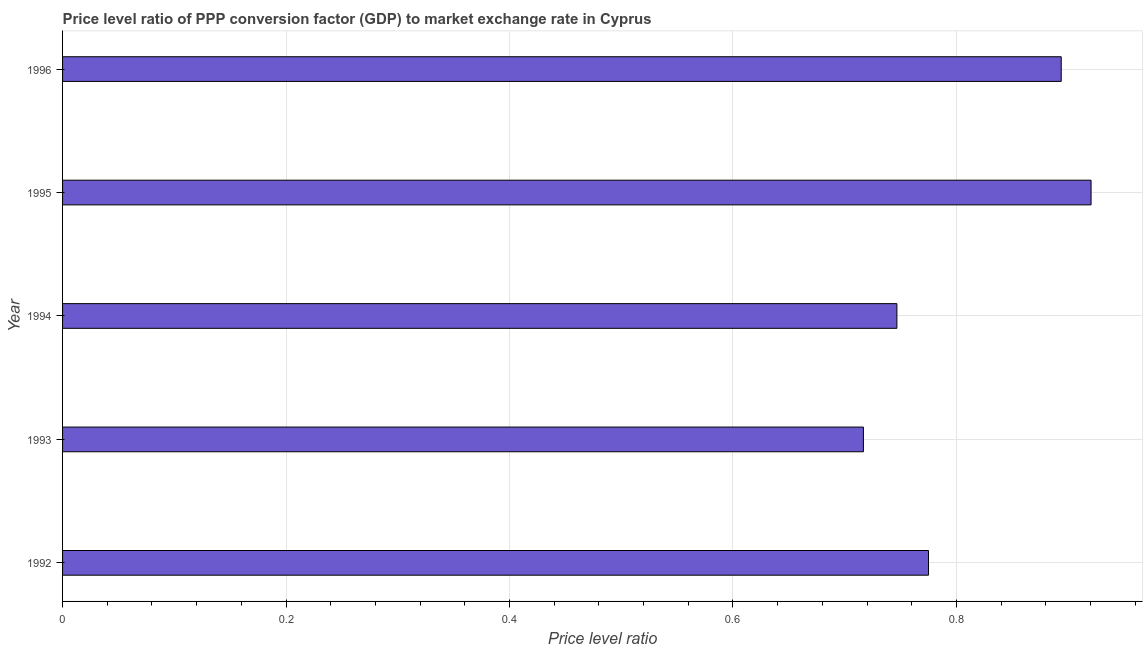Does the graph contain any zero values?
Keep it short and to the point. No. What is the title of the graph?
Provide a short and direct response. Price level ratio of PPP conversion factor (GDP) to market exchange rate in Cyprus. What is the label or title of the X-axis?
Your response must be concise. Price level ratio. What is the price level ratio in 1996?
Keep it short and to the point. 0.89. Across all years, what is the maximum price level ratio?
Your answer should be compact. 0.92. Across all years, what is the minimum price level ratio?
Offer a very short reply. 0.72. In which year was the price level ratio minimum?
Your answer should be very brief. 1993. What is the sum of the price level ratio?
Your answer should be very brief. 4.05. What is the difference between the price level ratio in 1992 and 1993?
Make the answer very short. 0.06. What is the average price level ratio per year?
Provide a succinct answer. 0.81. What is the median price level ratio?
Make the answer very short. 0.77. In how many years, is the price level ratio greater than 0.8 ?
Give a very brief answer. 2. What is the ratio of the price level ratio in 1995 to that in 1996?
Make the answer very short. 1.03. Is the price level ratio in 1993 less than that in 1994?
Your response must be concise. Yes. What is the difference between the highest and the second highest price level ratio?
Your answer should be very brief. 0.03. Is the sum of the price level ratio in 1993 and 1995 greater than the maximum price level ratio across all years?
Ensure brevity in your answer.  Yes. What is the difference between the highest and the lowest price level ratio?
Your response must be concise. 0.2. How many bars are there?
Your answer should be compact. 5. Are all the bars in the graph horizontal?
Give a very brief answer. Yes. How many years are there in the graph?
Offer a very short reply. 5. What is the Price level ratio of 1992?
Offer a very short reply. 0.77. What is the Price level ratio in 1993?
Keep it short and to the point. 0.72. What is the Price level ratio of 1994?
Provide a succinct answer. 0.75. What is the Price level ratio of 1995?
Your answer should be very brief. 0.92. What is the Price level ratio in 1996?
Provide a succinct answer. 0.89. What is the difference between the Price level ratio in 1992 and 1993?
Your answer should be very brief. 0.06. What is the difference between the Price level ratio in 1992 and 1994?
Provide a succinct answer. 0.03. What is the difference between the Price level ratio in 1992 and 1995?
Your answer should be very brief. -0.15. What is the difference between the Price level ratio in 1992 and 1996?
Make the answer very short. -0.12. What is the difference between the Price level ratio in 1993 and 1994?
Give a very brief answer. -0.03. What is the difference between the Price level ratio in 1993 and 1995?
Keep it short and to the point. -0.2. What is the difference between the Price level ratio in 1993 and 1996?
Your answer should be compact. -0.18. What is the difference between the Price level ratio in 1994 and 1995?
Make the answer very short. -0.17. What is the difference between the Price level ratio in 1994 and 1996?
Make the answer very short. -0.15. What is the difference between the Price level ratio in 1995 and 1996?
Offer a very short reply. 0.03. What is the ratio of the Price level ratio in 1992 to that in 1993?
Provide a succinct answer. 1.08. What is the ratio of the Price level ratio in 1992 to that in 1994?
Ensure brevity in your answer.  1.04. What is the ratio of the Price level ratio in 1992 to that in 1995?
Your response must be concise. 0.84. What is the ratio of the Price level ratio in 1992 to that in 1996?
Your response must be concise. 0.87. What is the ratio of the Price level ratio in 1993 to that in 1995?
Make the answer very short. 0.78. What is the ratio of the Price level ratio in 1993 to that in 1996?
Offer a terse response. 0.8. What is the ratio of the Price level ratio in 1994 to that in 1995?
Provide a succinct answer. 0.81. What is the ratio of the Price level ratio in 1994 to that in 1996?
Ensure brevity in your answer.  0.83. What is the ratio of the Price level ratio in 1995 to that in 1996?
Your answer should be very brief. 1.03. 